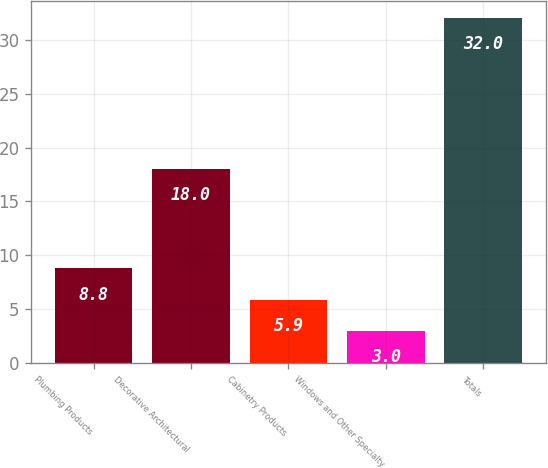Convert chart. <chart><loc_0><loc_0><loc_500><loc_500><bar_chart><fcel>Plumbing Products<fcel>Decorative Architectural<fcel>Cabinetry Products<fcel>Windows and Other Specialty<fcel>Totals<nl><fcel>8.8<fcel>18<fcel>5.9<fcel>3<fcel>32<nl></chart> 